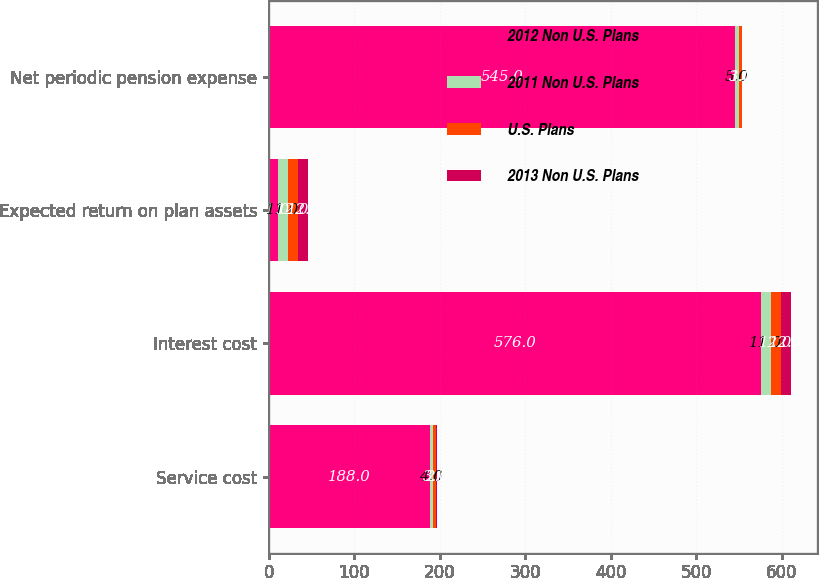<chart> <loc_0><loc_0><loc_500><loc_500><stacked_bar_chart><ecel><fcel>Service cost<fcel>Interest cost<fcel>Expected return on plan assets<fcel>Net periodic pension expense<nl><fcel>2012 Non U.S. Plans<fcel>188<fcel>576<fcel>11<fcel>545<nl><fcel>2011 Non U.S. Plans<fcel>4<fcel>11<fcel>11<fcel>5<nl><fcel>U.S. Plans<fcel>3<fcel>12<fcel>12<fcel>3<nl><fcel>2013 Non U.S. Plans<fcel>2<fcel>12<fcel>12<fcel>1<nl></chart> 